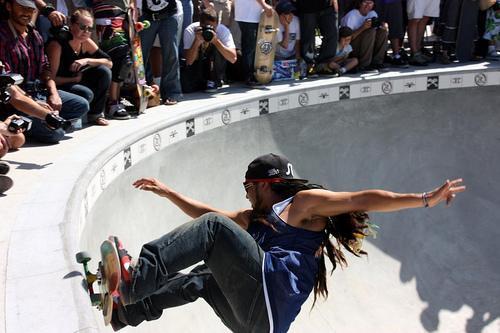What is the person in the foreground doing?
Select the correct answer and articulate reasoning with the following format: 'Answer: answer
Rationale: rationale.'
Options: Fishing, running, skateboarding, eating. Answer: skateboarding.
Rationale: The person is performing on a skateboard 